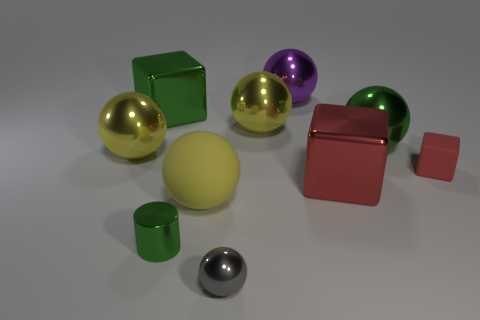What size is the cube that is the same color as the cylinder?
Give a very brief answer. Large. What number of other objects are there of the same color as the small metallic cylinder?
Ensure brevity in your answer.  2. What is the size of the green sphere?
Your answer should be compact. Large. Is the number of metallic blocks that are to the left of the cylinder greater than the number of metallic spheres that are in front of the gray ball?
Your response must be concise. Yes. There is a large yellow metal ball to the left of the tiny metallic cylinder; what number of purple metal objects are behind it?
Provide a short and direct response. 1. Is the shape of the green thing that is in front of the green shiny sphere the same as  the red rubber object?
Provide a short and direct response. No. What is the material of the green object that is the same shape as the big purple metal object?
Give a very brief answer. Metal. How many red rubber blocks are the same size as the gray metallic sphere?
Provide a succinct answer. 1. What color is the shiny object that is behind the red metallic object and right of the purple metal sphere?
Your answer should be compact. Green. Are there fewer metal things than big purple shiny balls?
Offer a very short reply. No. 